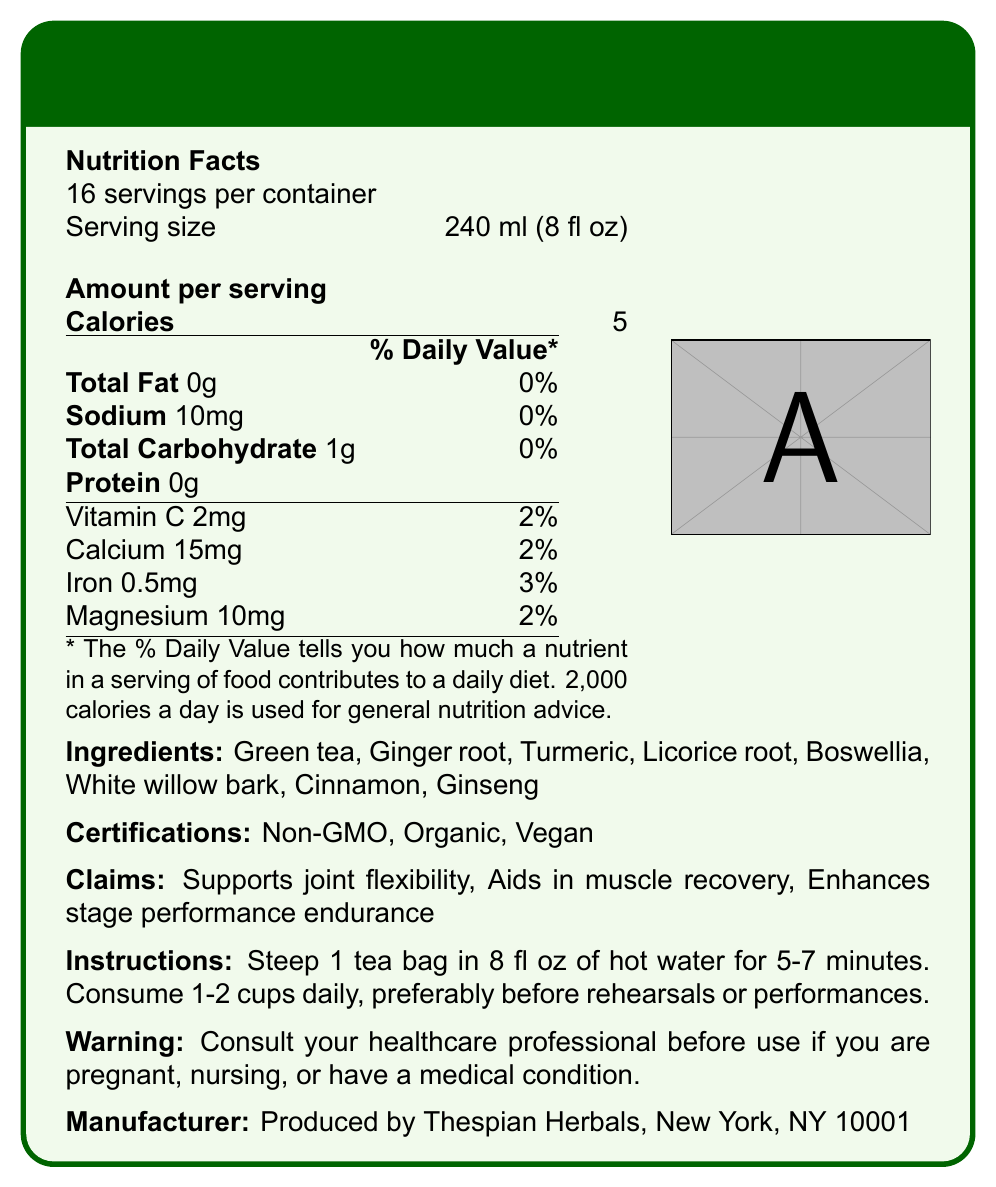what is the serving size? The document states that the serving size is 240 ml (8 fl oz).
Answer: 240 ml (8 fl oz) How many calories are in one serving? According to the Nutrition Facts, one serving contains 5 calories.
Answer: 5 calories What is the daily value percentage of sodium per serving? The document shows that the daily value percentage of sodium per serving is 0%.
Answer: 0% Which ingredient is listed first in the ingredients list? The first ingredient listed in the ingredients section is Green tea.
Answer: Green tea What should you do before using this product if you have a medical condition? The warning section advises consulting a healthcare professional if you have a medical condition.
Answer: Consult your healthcare professional How many servings does each container have? The document states there are 16 servings per container.
Answer: 16 servings What is the amount of iron per serving? The iron content per serving is listed as 0.5mg.
Answer: 0.5mg What are the certifications mentioned for this product? A. Gluten-Free, Non-GMO, Vegan B. Non-GMO, Organic, Vegan C. Organic, Fair Trade, Non-GMO The certifications section lists Non-GMO, Organic, and Vegan.
Answer: B. Non-GMO, Organic, Vegan Which minerals are present in this tea? A. Sodium, Calcium, Iron, Vitamin C B. Potassium, Calcium, Zinc, Magnesium C. Sodium, Calcium, Iron, Magnesium According to the Nutrition Facts, the minerals present include Sodium, Calcium, Iron, and Magnesium.
Answer: C. Sodium, Calcium, Iron, Magnesium Does this tea contain protein? The document states the protein content is 0g.
Answer: No Summarize the main idea of the document. The document is about FlexiTea, an herbal tea blend geared towards stage performers for enhancing flexibility, muscle recovery, and endurance. It lists ingredients, nutritional facts, certifications, and usage instructions.
Answer: FlexiTea: Asian Herbal Blend for Stage Performers is a specialized herbal tea designed to support joint flexibility, aid muscle recovery, and enhance stage performance endurance. It includes ingredients such as Green tea, Ginger root, and Turmeric. The tea is Non-GMO, Organic, and Vegan, with instructions to consume 1-2 cups daily before rehearsals or performances. Who produces FlexiTea? The manufacturer information section states that FlexiTea is produced by Thespian Herbals, New York, NY 10001.
Answer: Thespian Herbals What benefits does the tea claim to offer? The claims section lists these benefits.
Answer: Supports joint flexibility, Aids in muscle recovery, Enhances stage performance endurance Is it safe for pregnant women to drink this tea without medical advice? The warning section advises consulting a healthcare professional before use if pregnant.
Answer: No How long should you steep the tea bag in hot water? The instructions section advises steeping 1 tea bag in 8 fl oz of hot water for 5-7 minutes.
Answer: 5-7 minutes What is the price of FlexiTea? There is no price information provided in the document.
Answer: Cannot be determined 